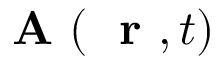<formula> <loc_0><loc_0><loc_500><loc_500>A ( r , t )</formula> 